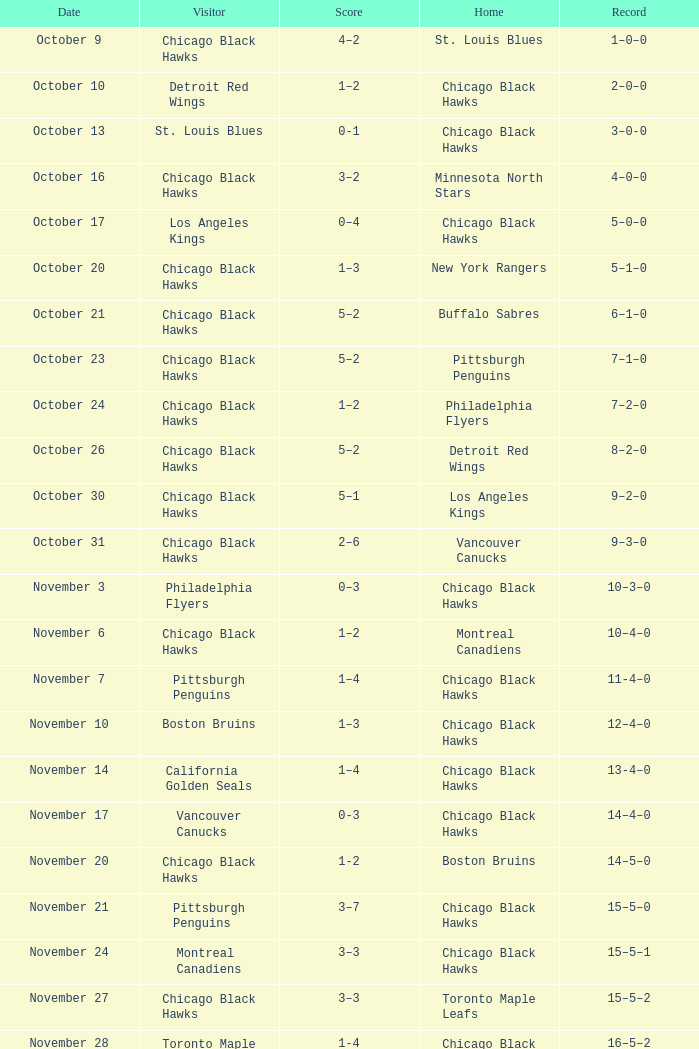What is the document of the february 26 date? 39–16–7. 